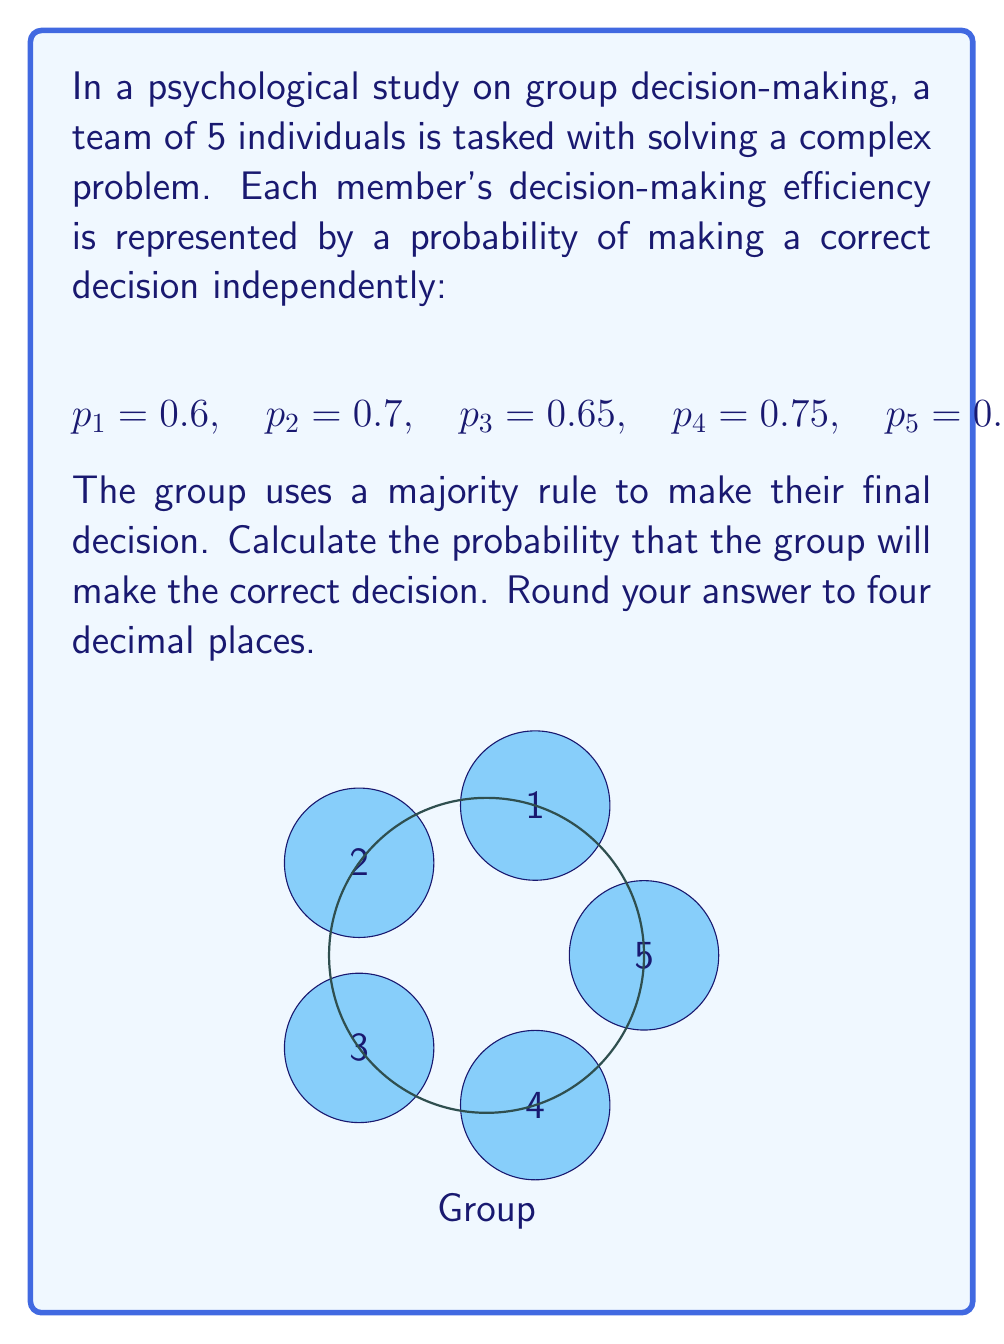Provide a solution to this math problem. To solve this problem, we'll use the concept of the majority rule and probability theory. Here's a step-by-step explanation:

1) First, we need to calculate the probability of at least 3 out of 5 members making the correct decision.

2) We can use the complement of the probability of 0, 1, or 2 members making the correct decision:

   $$P(\text{correct group decision}) = 1 - P(0\text{ or }1\text{ or }2\text{ correct})$$

3) Let's calculate the probability of exactly k members being correct using the binomial probability formula:

   $$P(X = k) = \sum_{S \in C(5,k)} \prod_{i \in S} p_i \prod_{j \notin S} (1-p_j)$$

   where $C(5,k)$ is the set of all combinations of 5 choose k.

4) For k = 0:
   $$P(X = 0) = (1-0.6)(1-0.7)(1-0.65)(1-0.75)(1-0.8) = 0.0006$$

5) For k = 1:
   $$P(X = 1) = 0.6(1-0.7)(1-0.65)(1-0.75)(1-0.8) + \ldots + (1-0.6)(1-0.7)(1-0.65)(1-0.75)0.8 = 0.0124$$

6) For k = 2:
   $$P(X = 2) = 0.6 \cdot 0.7(1-0.65)(1-0.75)(1-0.8) + \ldots + (1-0.6)(1-0.7)0.65 \cdot 0.75 \cdot 0.8 = 0.0914$$

7) Therefore, the probability of the group making the correct decision is:

   $$P(\text{correct group decision}) = 1 - (P(X = 0) + P(X = 1) + P(X = 2))$$
   $$= 1 - (0.0006 + 0.0124 + 0.0914) = 0.8956$$

8) Rounding to four decimal places: 0.8956
Answer: 0.8956 